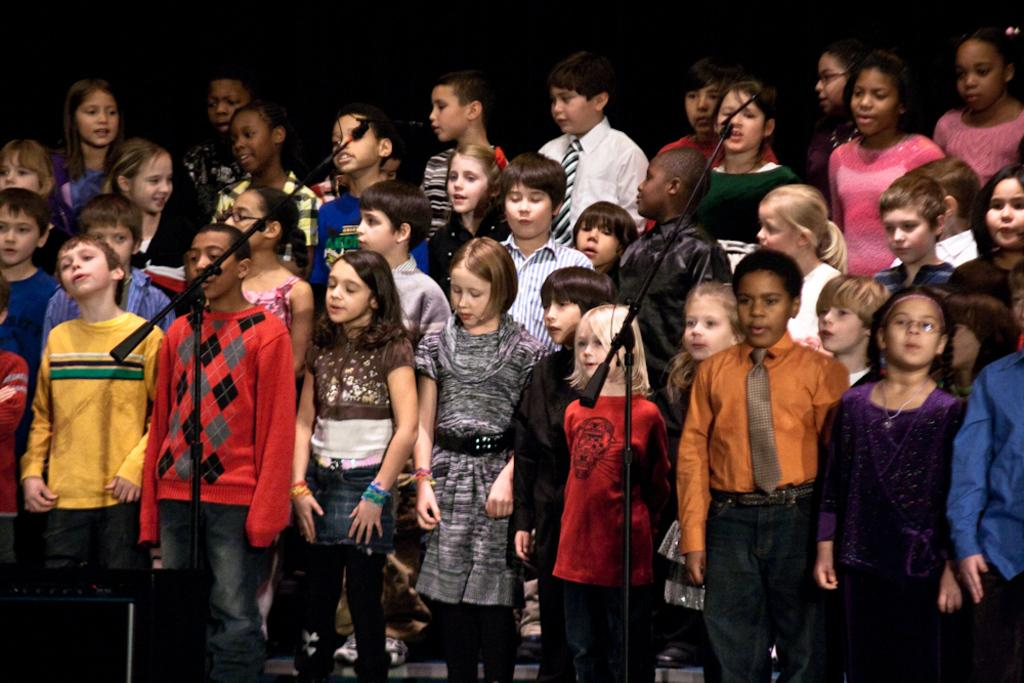How many people are in the image? There are persons standing in the image. What objects are in the foreground of the image? There are microphones and a sound box in the foreground of the image. How many dogs are playing with balls in the image? There are no dogs or balls present in the image. What type of iron is being used to press the clothes in the image? There is no iron or clothes-pressing activity depicted in the image. 